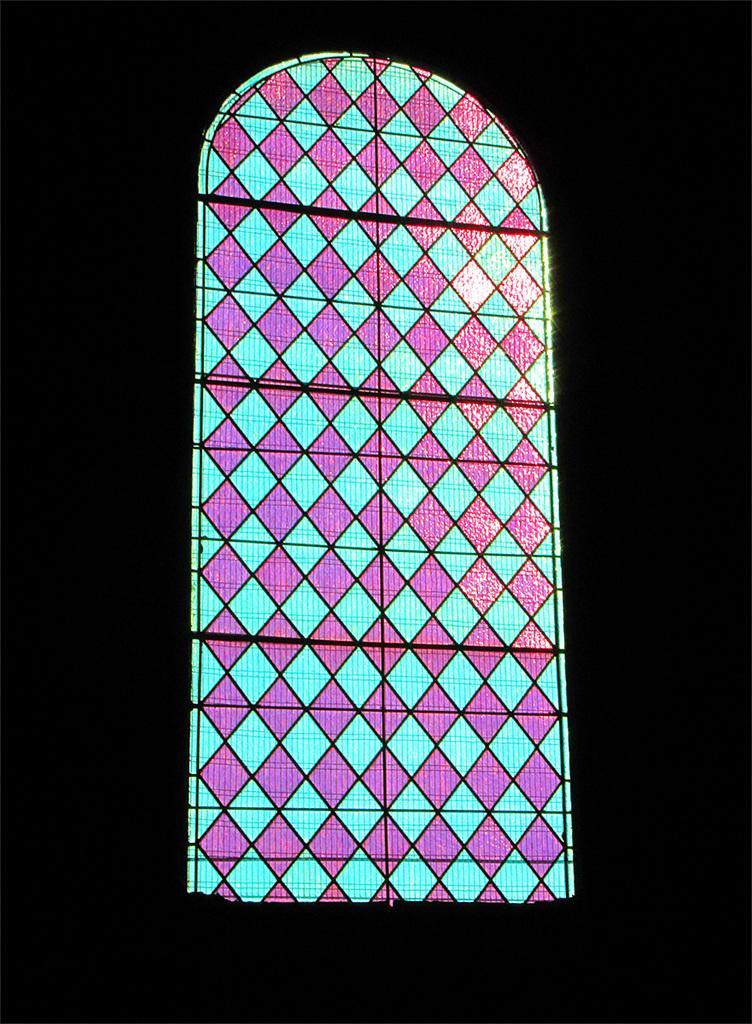Could you give a brief overview of what you see in this image? In this image we can see a glass window. 